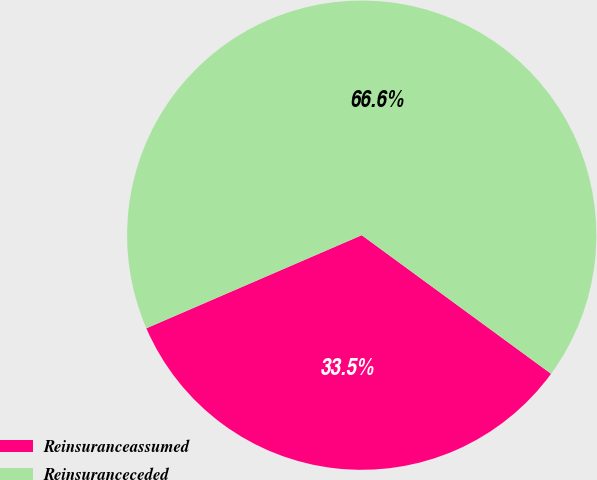<chart> <loc_0><loc_0><loc_500><loc_500><pie_chart><fcel>Reinsuranceassumed<fcel>Reinsuranceceded<nl><fcel>33.45%<fcel>66.55%<nl></chart> 